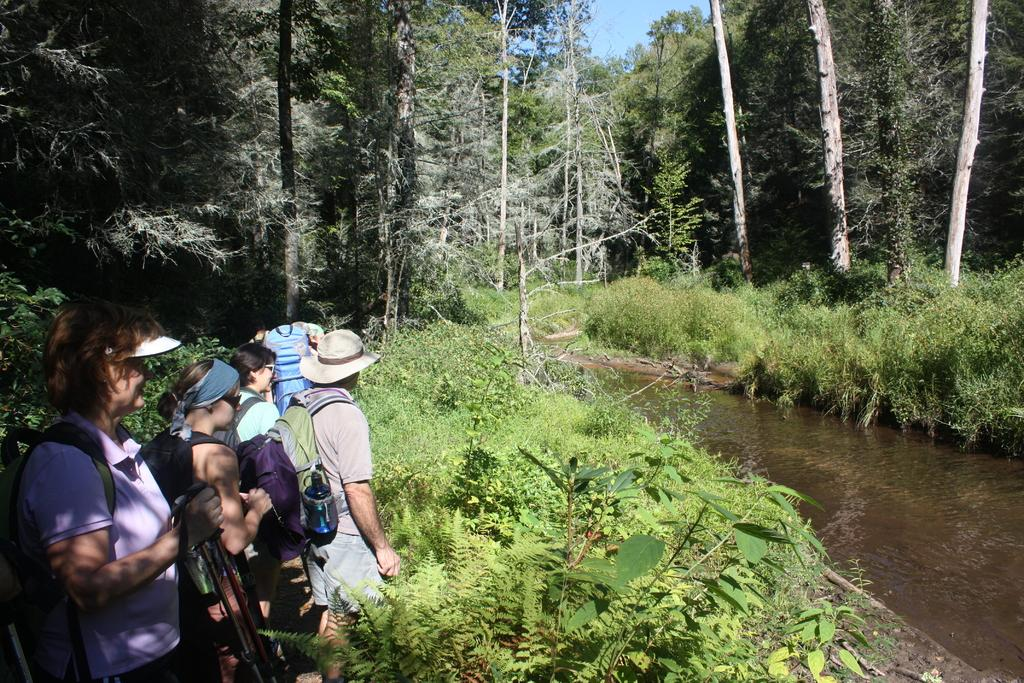What are the persons in the image doing? standing on the ground? What can be seen on the persons' backs in the image? The persons in the image are wearing backpacks. What type of vegetation is present in the image? There are plants, shrubs, bushes, and trees visible in the image. What is the ground made of in the image? The ground is covered with grass, as mentioned in the facts. What is the liquid element in the image? There is water in the image. What part of the natural environment is visible in the image? The sky is visible in the image. How many ears of corn are visible in the image? There is no corn present in the image. What type of step is used to climb the trees in the image? There is no mention of climbing trees or steps in the image. 